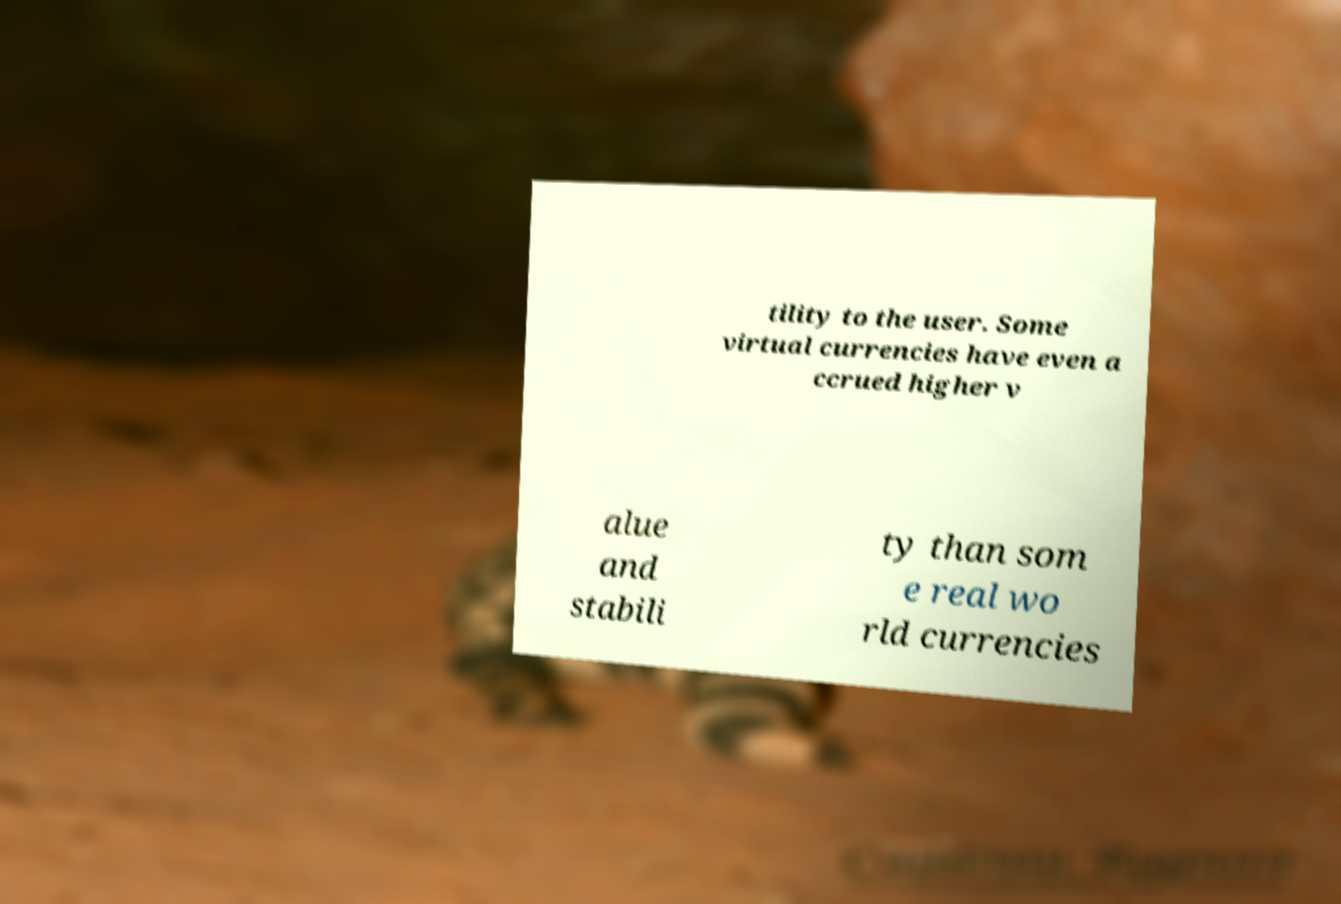Please identify and transcribe the text found in this image. tility to the user. Some virtual currencies have even a ccrued higher v alue and stabili ty than som e real wo rld currencies 